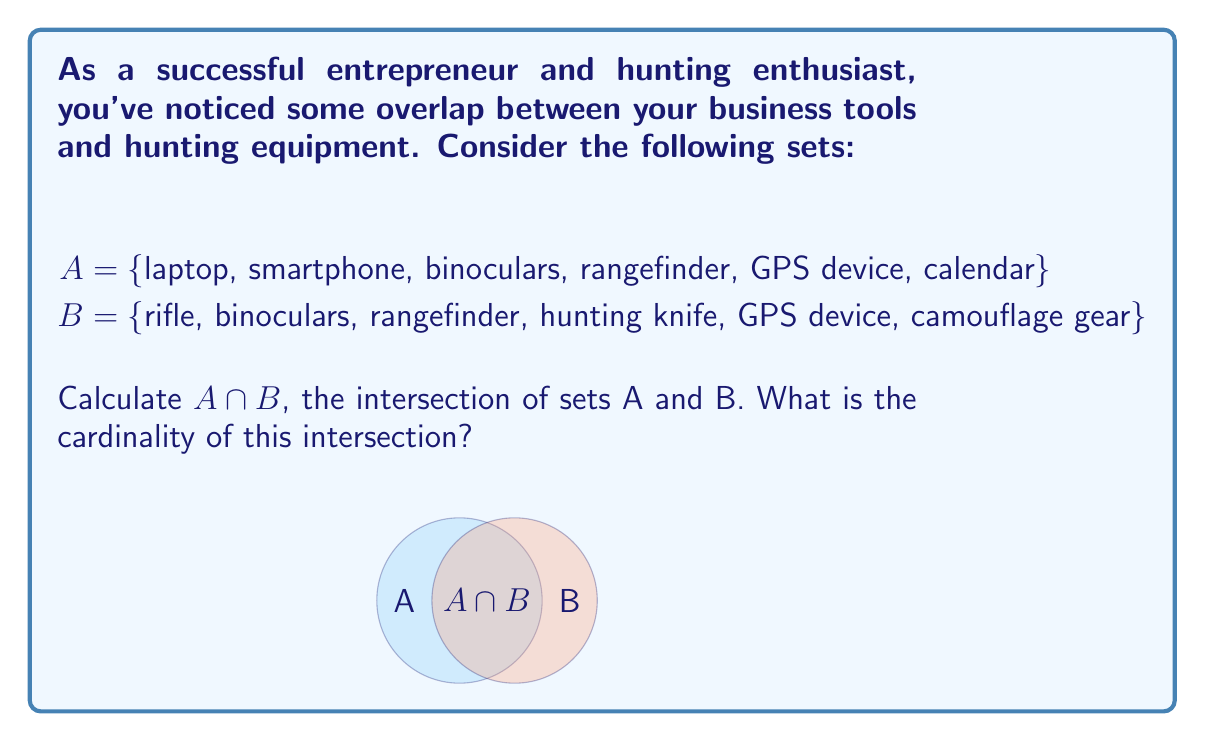Teach me how to tackle this problem. To solve this problem, we need to follow these steps:

1) Identify the elements that are common to both sets A and B.

2) List these common elements to form the intersection set.

3) Count the number of elements in the intersection to determine its cardinality.

Let's proceed:

1) Examining sets A and B, we find:
   - binoculars is in both A and B
   - rangefinder is in both A and B
   - GPS device is in both A and B

2) Therefore, the intersection of A and B is:
   $A \cap B = \{binoculars, rangefinder, GPS device\}$

3) To find the cardinality, we count the number of elements in $A \cap B$:
   $|A \cap B| = 3$

The intersection contains 3 elements, which represents the overlap between your business tools and hunting equipment.
Answer: $|A \cap B| = 3$ 